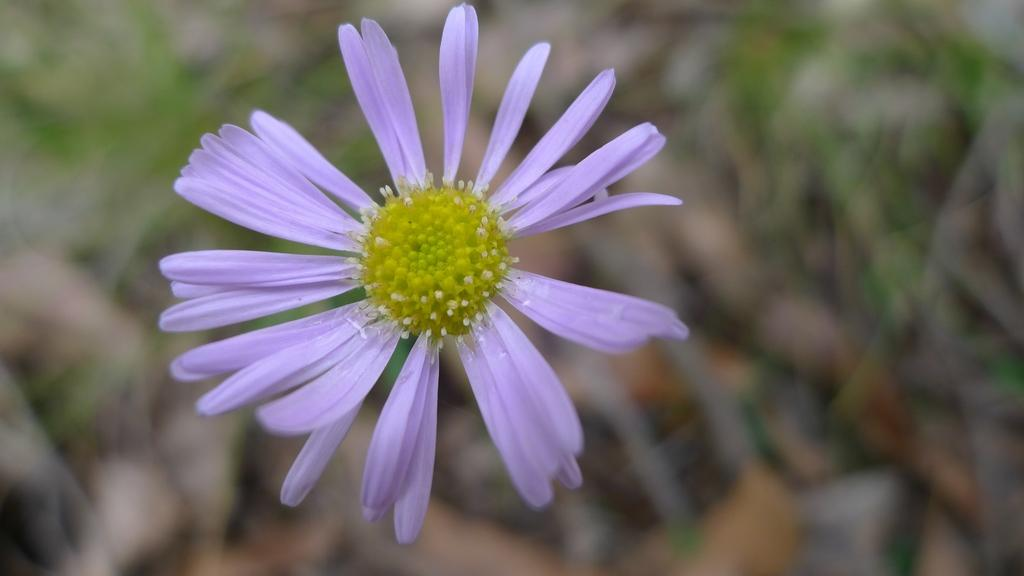What is the main subject of the image? The main subject of the image is a flower. What colors can be seen on the flower? The flower has purple and green colors. Can you describe the background of the image? The background of the image is blurred. How many requests does the flower receive in the image? There are no requests present in the image, as it features a flower with no indication of any requests being made. 